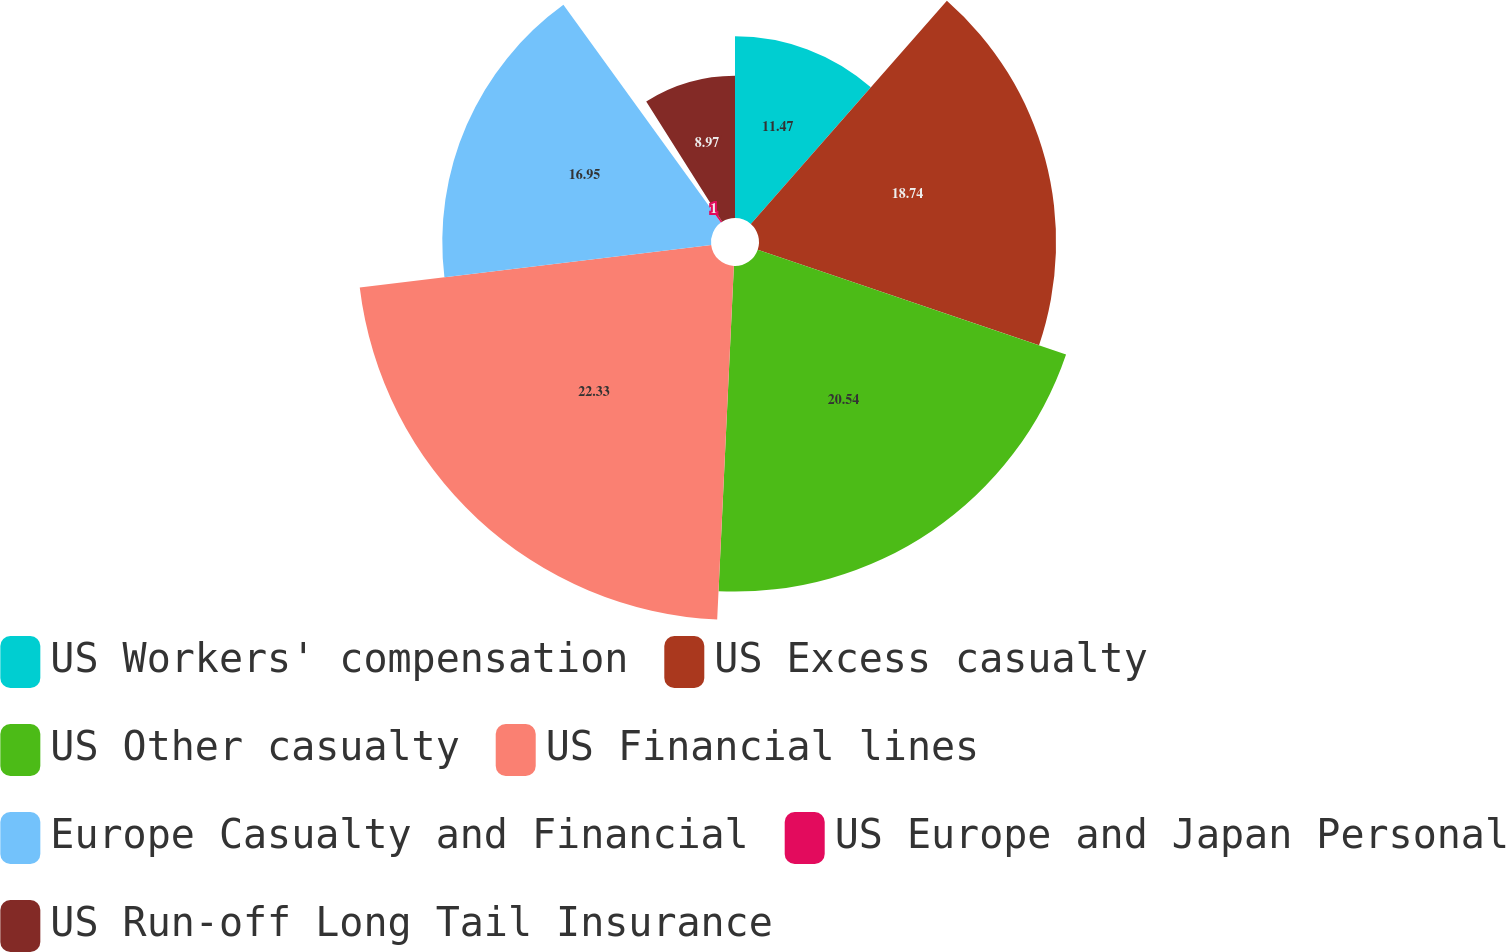Convert chart. <chart><loc_0><loc_0><loc_500><loc_500><pie_chart><fcel>US Workers' compensation<fcel>US Excess casualty<fcel>US Other casualty<fcel>US Financial lines<fcel>Europe Casualty and Financial<fcel>US Europe and Japan Personal<fcel>US Run-off Long Tail Insurance<nl><fcel>11.47%<fcel>18.74%<fcel>20.54%<fcel>22.33%<fcel>16.95%<fcel>1.0%<fcel>8.97%<nl></chart> 